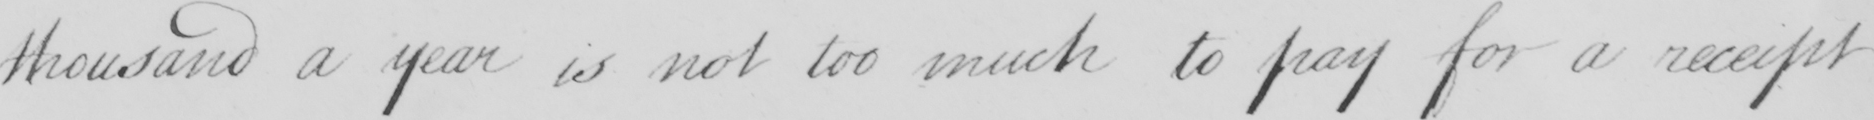Please transcribe the handwritten text in this image. thousand a year is not too much to pay for a receipt 